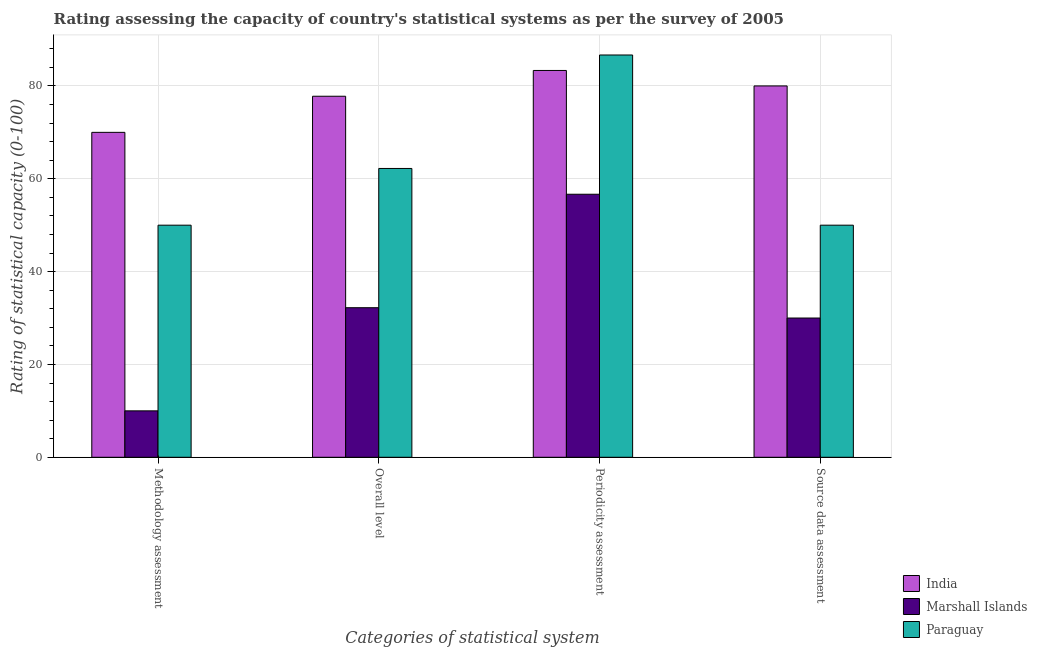Are the number of bars on each tick of the X-axis equal?
Offer a very short reply. Yes. How many bars are there on the 2nd tick from the right?
Offer a terse response. 3. What is the label of the 1st group of bars from the left?
Your answer should be very brief. Methodology assessment. What is the periodicity assessment rating in Marshall Islands?
Provide a short and direct response. 56.67. Across all countries, what is the maximum periodicity assessment rating?
Provide a short and direct response. 86.67. In which country was the methodology assessment rating minimum?
Give a very brief answer. Marshall Islands. What is the total periodicity assessment rating in the graph?
Your answer should be very brief. 226.67. What is the difference between the periodicity assessment rating in Paraguay and that in India?
Your response must be concise. 3.33. What is the difference between the periodicity assessment rating in Marshall Islands and the methodology assessment rating in Paraguay?
Make the answer very short. 6.67. What is the average source data assessment rating per country?
Your answer should be very brief. 53.33. What is the difference between the source data assessment rating and overall level rating in Marshall Islands?
Keep it short and to the point. -2.22. In how many countries, is the periodicity assessment rating greater than 44 ?
Ensure brevity in your answer.  3. What is the ratio of the periodicity assessment rating in Paraguay to that in India?
Your answer should be compact. 1.04. Is the difference between the overall level rating in Paraguay and Marshall Islands greater than the difference between the methodology assessment rating in Paraguay and Marshall Islands?
Provide a short and direct response. No. What is the difference between the highest and the second highest methodology assessment rating?
Your response must be concise. 20. What is the difference between the highest and the lowest methodology assessment rating?
Provide a succinct answer. 60. In how many countries, is the methodology assessment rating greater than the average methodology assessment rating taken over all countries?
Keep it short and to the point. 2. What does the 2nd bar from the left in Periodicity assessment represents?
Provide a succinct answer. Marshall Islands. What does the 2nd bar from the right in Methodology assessment represents?
Offer a terse response. Marshall Islands. How many bars are there?
Offer a terse response. 12. Are the values on the major ticks of Y-axis written in scientific E-notation?
Provide a succinct answer. No. Does the graph contain any zero values?
Offer a terse response. No. Where does the legend appear in the graph?
Make the answer very short. Bottom right. How are the legend labels stacked?
Give a very brief answer. Vertical. What is the title of the graph?
Offer a very short reply. Rating assessing the capacity of country's statistical systems as per the survey of 2005 . Does "Liechtenstein" appear as one of the legend labels in the graph?
Keep it short and to the point. No. What is the label or title of the X-axis?
Your answer should be compact. Categories of statistical system. What is the label or title of the Y-axis?
Give a very brief answer. Rating of statistical capacity (0-100). What is the Rating of statistical capacity (0-100) of Paraguay in Methodology assessment?
Give a very brief answer. 50. What is the Rating of statistical capacity (0-100) of India in Overall level?
Your response must be concise. 77.78. What is the Rating of statistical capacity (0-100) in Marshall Islands in Overall level?
Make the answer very short. 32.22. What is the Rating of statistical capacity (0-100) of Paraguay in Overall level?
Make the answer very short. 62.22. What is the Rating of statistical capacity (0-100) of India in Periodicity assessment?
Offer a very short reply. 83.33. What is the Rating of statistical capacity (0-100) in Marshall Islands in Periodicity assessment?
Keep it short and to the point. 56.67. What is the Rating of statistical capacity (0-100) of Paraguay in Periodicity assessment?
Your answer should be compact. 86.67. What is the Rating of statistical capacity (0-100) of Paraguay in Source data assessment?
Offer a terse response. 50. Across all Categories of statistical system, what is the maximum Rating of statistical capacity (0-100) in India?
Your answer should be compact. 83.33. Across all Categories of statistical system, what is the maximum Rating of statistical capacity (0-100) in Marshall Islands?
Provide a succinct answer. 56.67. Across all Categories of statistical system, what is the maximum Rating of statistical capacity (0-100) in Paraguay?
Offer a terse response. 86.67. Across all Categories of statistical system, what is the minimum Rating of statistical capacity (0-100) of Marshall Islands?
Offer a very short reply. 10. Across all Categories of statistical system, what is the minimum Rating of statistical capacity (0-100) of Paraguay?
Your answer should be very brief. 50. What is the total Rating of statistical capacity (0-100) of India in the graph?
Ensure brevity in your answer.  311.11. What is the total Rating of statistical capacity (0-100) in Marshall Islands in the graph?
Offer a very short reply. 128.89. What is the total Rating of statistical capacity (0-100) in Paraguay in the graph?
Make the answer very short. 248.89. What is the difference between the Rating of statistical capacity (0-100) of India in Methodology assessment and that in Overall level?
Make the answer very short. -7.78. What is the difference between the Rating of statistical capacity (0-100) of Marshall Islands in Methodology assessment and that in Overall level?
Give a very brief answer. -22.22. What is the difference between the Rating of statistical capacity (0-100) in Paraguay in Methodology assessment and that in Overall level?
Keep it short and to the point. -12.22. What is the difference between the Rating of statistical capacity (0-100) in India in Methodology assessment and that in Periodicity assessment?
Provide a succinct answer. -13.33. What is the difference between the Rating of statistical capacity (0-100) in Marshall Islands in Methodology assessment and that in Periodicity assessment?
Make the answer very short. -46.67. What is the difference between the Rating of statistical capacity (0-100) in Paraguay in Methodology assessment and that in Periodicity assessment?
Your response must be concise. -36.67. What is the difference between the Rating of statistical capacity (0-100) in India in Overall level and that in Periodicity assessment?
Make the answer very short. -5.56. What is the difference between the Rating of statistical capacity (0-100) of Marshall Islands in Overall level and that in Periodicity assessment?
Offer a very short reply. -24.44. What is the difference between the Rating of statistical capacity (0-100) of Paraguay in Overall level and that in Periodicity assessment?
Ensure brevity in your answer.  -24.44. What is the difference between the Rating of statistical capacity (0-100) of India in Overall level and that in Source data assessment?
Provide a short and direct response. -2.22. What is the difference between the Rating of statistical capacity (0-100) of Marshall Islands in Overall level and that in Source data assessment?
Ensure brevity in your answer.  2.22. What is the difference between the Rating of statistical capacity (0-100) in Paraguay in Overall level and that in Source data assessment?
Ensure brevity in your answer.  12.22. What is the difference between the Rating of statistical capacity (0-100) in India in Periodicity assessment and that in Source data assessment?
Give a very brief answer. 3.33. What is the difference between the Rating of statistical capacity (0-100) of Marshall Islands in Periodicity assessment and that in Source data assessment?
Offer a terse response. 26.67. What is the difference between the Rating of statistical capacity (0-100) in Paraguay in Periodicity assessment and that in Source data assessment?
Give a very brief answer. 36.67. What is the difference between the Rating of statistical capacity (0-100) of India in Methodology assessment and the Rating of statistical capacity (0-100) of Marshall Islands in Overall level?
Provide a succinct answer. 37.78. What is the difference between the Rating of statistical capacity (0-100) in India in Methodology assessment and the Rating of statistical capacity (0-100) in Paraguay in Overall level?
Give a very brief answer. 7.78. What is the difference between the Rating of statistical capacity (0-100) of Marshall Islands in Methodology assessment and the Rating of statistical capacity (0-100) of Paraguay in Overall level?
Provide a succinct answer. -52.22. What is the difference between the Rating of statistical capacity (0-100) in India in Methodology assessment and the Rating of statistical capacity (0-100) in Marshall Islands in Periodicity assessment?
Make the answer very short. 13.33. What is the difference between the Rating of statistical capacity (0-100) of India in Methodology assessment and the Rating of statistical capacity (0-100) of Paraguay in Periodicity assessment?
Offer a very short reply. -16.67. What is the difference between the Rating of statistical capacity (0-100) of Marshall Islands in Methodology assessment and the Rating of statistical capacity (0-100) of Paraguay in Periodicity assessment?
Give a very brief answer. -76.67. What is the difference between the Rating of statistical capacity (0-100) in India in Methodology assessment and the Rating of statistical capacity (0-100) in Paraguay in Source data assessment?
Provide a succinct answer. 20. What is the difference between the Rating of statistical capacity (0-100) of Marshall Islands in Methodology assessment and the Rating of statistical capacity (0-100) of Paraguay in Source data assessment?
Your answer should be very brief. -40. What is the difference between the Rating of statistical capacity (0-100) in India in Overall level and the Rating of statistical capacity (0-100) in Marshall Islands in Periodicity assessment?
Ensure brevity in your answer.  21.11. What is the difference between the Rating of statistical capacity (0-100) of India in Overall level and the Rating of statistical capacity (0-100) of Paraguay in Periodicity assessment?
Offer a terse response. -8.89. What is the difference between the Rating of statistical capacity (0-100) of Marshall Islands in Overall level and the Rating of statistical capacity (0-100) of Paraguay in Periodicity assessment?
Provide a short and direct response. -54.44. What is the difference between the Rating of statistical capacity (0-100) in India in Overall level and the Rating of statistical capacity (0-100) in Marshall Islands in Source data assessment?
Ensure brevity in your answer.  47.78. What is the difference between the Rating of statistical capacity (0-100) in India in Overall level and the Rating of statistical capacity (0-100) in Paraguay in Source data assessment?
Provide a short and direct response. 27.78. What is the difference between the Rating of statistical capacity (0-100) in Marshall Islands in Overall level and the Rating of statistical capacity (0-100) in Paraguay in Source data assessment?
Your response must be concise. -17.78. What is the difference between the Rating of statistical capacity (0-100) of India in Periodicity assessment and the Rating of statistical capacity (0-100) of Marshall Islands in Source data assessment?
Your answer should be compact. 53.33. What is the difference between the Rating of statistical capacity (0-100) in India in Periodicity assessment and the Rating of statistical capacity (0-100) in Paraguay in Source data assessment?
Offer a very short reply. 33.33. What is the average Rating of statistical capacity (0-100) in India per Categories of statistical system?
Your answer should be compact. 77.78. What is the average Rating of statistical capacity (0-100) of Marshall Islands per Categories of statistical system?
Provide a succinct answer. 32.22. What is the average Rating of statistical capacity (0-100) of Paraguay per Categories of statistical system?
Your response must be concise. 62.22. What is the difference between the Rating of statistical capacity (0-100) in India and Rating of statistical capacity (0-100) in Marshall Islands in Methodology assessment?
Your answer should be compact. 60. What is the difference between the Rating of statistical capacity (0-100) of India and Rating of statistical capacity (0-100) of Paraguay in Methodology assessment?
Offer a terse response. 20. What is the difference between the Rating of statistical capacity (0-100) of Marshall Islands and Rating of statistical capacity (0-100) of Paraguay in Methodology assessment?
Your response must be concise. -40. What is the difference between the Rating of statistical capacity (0-100) in India and Rating of statistical capacity (0-100) in Marshall Islands in Overall level?
Your response must be concise. 45.56. What is the difference between the Rating of statistical capacity (0-100) in India and Rating of statistical capacity (0-100) in Paraguay in Overall level?
Your answer should be very brief. 15.56. What is the difference between the Rating of statistical capacity (0-100) of India and Rating of statistical capacity (0-100) of Marshall Islands in Periodicity assessment?
Your response must be concise. 26.67. What is the difference between the Rating of statistical capacity (0-100) in Marshall Islands and Rating of statistical capacity (0-100) in Paraguay in Periodicity assessment?
Offer a terse response. -30. What is the difference between the Rating of statistical capacity (0-100) in India and Rating of statistical capacity (0-100) in Marshall Islands in Source data assessment?
Give a very brief answer. 50. What is the difference between the Rating of statistical capacity (0-100) in India and Rating of statistical capacity (0-100) in Paraguay in Source data assessment?
Your answer should be very brief. 30. What is the difference between the Rating of statistical capacity (0-100) of Marshall Islands and Rating of statistical capacity (0-100) of Paraguay in Source data assessment?
Keep it short and to the point. -20. What is the ratio of the Rating of statistical capacity (0-100) in Marshall Islands in Methodology assessment to that in Overall level?
Give a very brief answer. 0.31. What is the ratio of the Rating of statistical capacity (0-100) of Paraguay in Methodology assessment to that in Overall level?
Offer a very short reply. 0.8. What is the ratio of the Rating of statistical capacity (0-100) of India in Methodology assessment to that in Periodicity assessment?
Make the answer very short. 0.84. What is the ratio of the Rating of statistical capacity (0-100) in Marshall Islands in Methodology assessment to that in Periodicity assessment?
Keep it short and to the point. 0.18. What is the ratio of the Rating of statistical capacity (0-100) in Paraguay in Methodology assessment to that in Periodicity assessment?
Give a very brief answer. 0.58. What is the ratio of the Rating of statistical capacity (0-100) in India in Overall level to that in Periodicity assessment?
Provide a succinct answer. 0.93. What is the ratio of the Rating of statistical capacity (0-100) in Marshall Islands in Overall level to that in Periodicity assessment?
Your response must be concise. 0.57. What is the ratio of the Rating of statistical capacity (0-100) in Paraguay in Overall level to that in Periodicity assessment?
Your answer should be very brief. 0.72. What is the ratio of the Rating of statistical capacity (0-100) of India in Overall level to that in Source data assessment?
Keep it short and to the point. 0.97. What is the ratio of the Rating of statistical capacity (0-100) in Marshall Islands in Overall level to that in Source data assessment?
Provide a succinct answer. 1.07. What is the ratio of the Rating of statistical capacity (0-100) in Paraguay in Overall level to that in Source data assessment?
Your answer should be very brief. 1.24. What is the ratio of the Rating of statistical capacity (0-100) in India in Periodicity assessment to that in Source data assessment?
Your response must be concise. 1.04. What is the ratio of the Rating of statistical capacity (0-100) in Marshall Islands in Periodicity assessment to that in Source data assessment?
Provide a succinct answer. 1.89. What is the ratio of the Rating of statistical capacity (0-100) in Paraguay in Periodicity assessment to that in Source data assessment?
Your answer should be very brief. 1.73. What is the difference between the highest and the second highest Rating of statistical capacity (0-100) in Marshall Islands?
Provide a short and direct response. 24.44. What is the difference between the highest and the second highest Rating of statistical capacity (0-100) of Paraguay?
Provide a short and direct response. 24.44. What is the difference between the highest and the lowest Rating of statistical capacity (0-100) in India?
Offer a very short reply. 13.33. What is the difference between the highest and the lowest Rating of statistical capacity (0-100) in Marshall Islands?
Ensure brevity in your answer.  46.67. What is the difference between the highest and the lowest Rating of statistical capacity (0-100) of Paraguay?
Your answer should be compact. 36.67. 